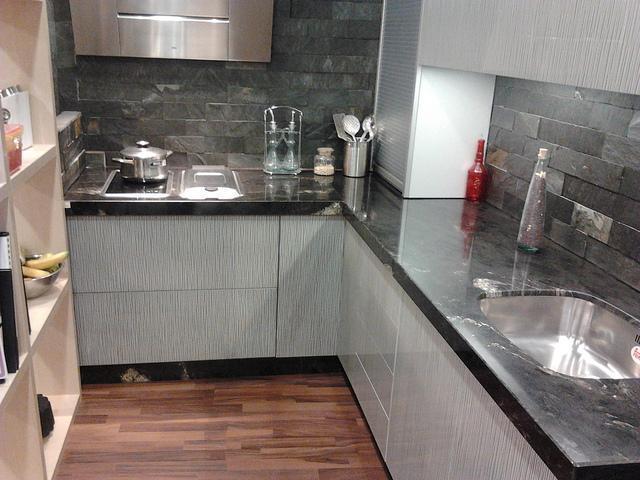How many people are wearing a red shirt?
Give a very brief answer. 0. 